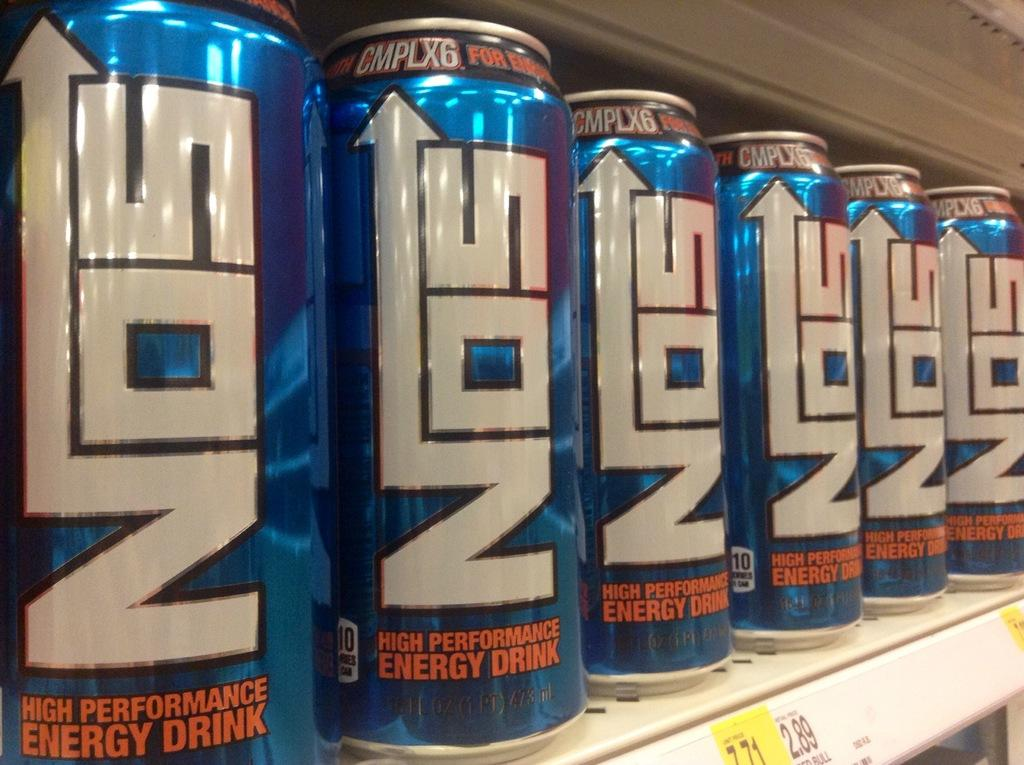<image>
Provide a brief description of the given image. NOS Engery drinks are lined up on a grocery store shelf. 